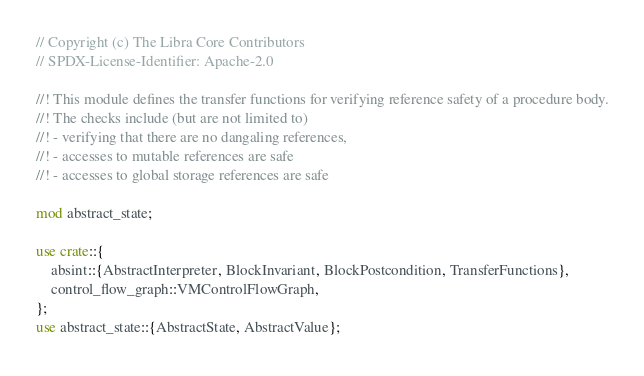Convert code to text. <code><loc_0><loc_0><loc_500><loc_500><_Rust_>// Copyright (c) The Libra Core Contributors
// SPDX-License-Identifier: Apache-2.0

//! This module defines the transfer functions for verifying reference safety of a procedure body.
//! The checks include (but are not limited to)
//! - verifying that there are no dangaling references,
//! - accesses to mutable references are safe
//! - accesses to global storage references are safe

mod abstract_state;

use crate::{
    absint::{AbstractInterpreter, BlockInvariant, BlockPostcondition, TransferFunctions},
    control_flow_graph::VMControlFlowGraph,
};
use abstract_state::{AbstractState, AbstractValue};</code> 